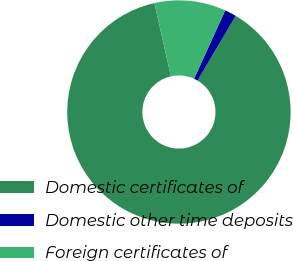Convert chart to OTSL. <chart><loc_0><loc_0><loc_500><loc_500><pie_chart><fcel>Domestic certificates of<fcel>Domestic other time deposits<fcel>Foreign certificates of<nl><fcel>87.99%<fcel>1.69%<fcel>10.32%<nl></chart> 